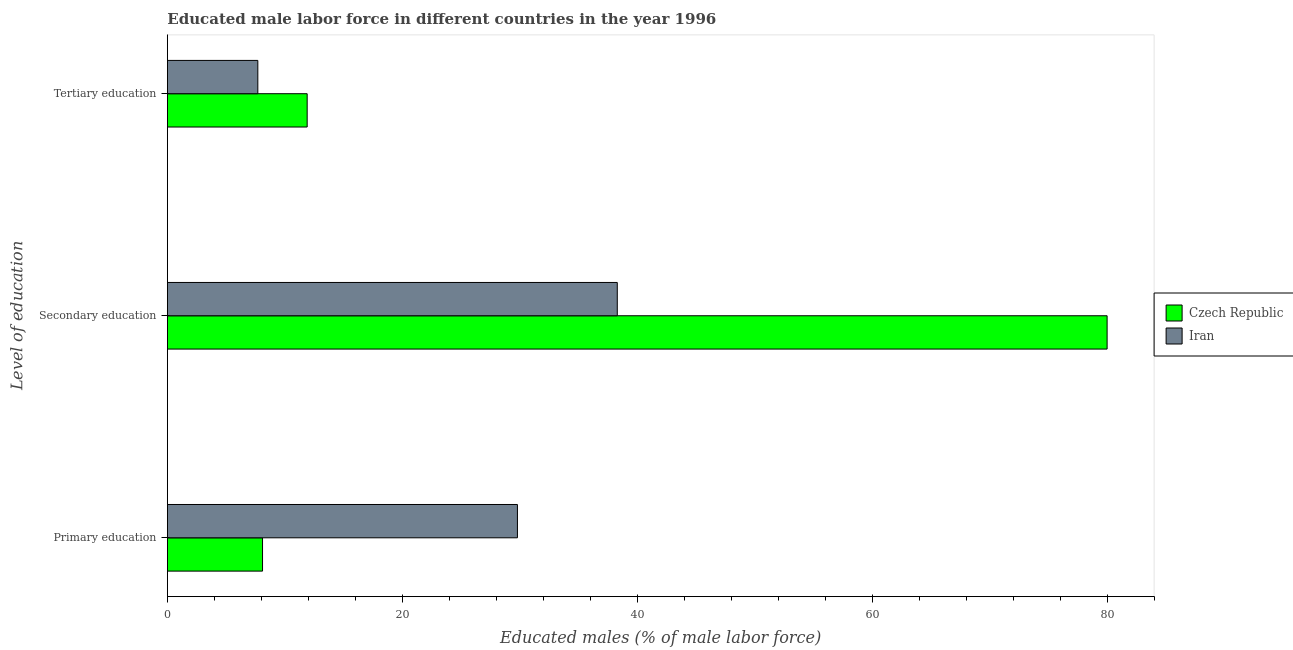How many different coloured bars are there?
Make the answer very short. 2. How many bars are there on the 3rd tick from the top?
Your answer should be compact. 2. How many bars are there on the 3rd tick from the bottom?
Keep it short and to the point. 2. What is the label of the 1st group of bars from the top?
Offer a terse response. Tertiary education. What is the percentage of male labor force who received secondary education in Iran?
Provide a short and direct response. 38.3. Across all countries, what is the maximum percentage of male labor force who received primary education?
Your response must be concise. 29.8. Across all countries, what is the minimum percentage of male labor force who received primary education?
Offer a very short reply. 8.1. In which country was the percentage of male labor force who received primary education maximum?
Provide a short and direct response. Iran. In which country was the percentage of male labor force who received tertiary education minimum?
Make the answer very short. Iran. What is the total percentage of male labor force who received secondary education in the graph?
Give a very brief answer. 118.3. What is the difference between the percentage of male labor force who received tertiary education in Czech Republic and that in Iran?
Give a very brief answer. 4.2. What is the difference between the percentage of male labor force who received secondary education in Czech Republic and the percentage of male labor force who received tertiary education in Iran?
Offer a very short reply. 72.3. What is the average percentage of male labor force who received primary education per country?
Your response must be concise. 18.95. What is the difference between the percentage of male labor force who received primary education and percentage of male labor force who received tertiary education in Iran?
Your answer should be compact. 22.1. In how many countries, is the percentage of male labor force who received tertiary education greater than 32 %?
Your answer should be very brief. 0. What is the ratio of the percentage of male labor force who received secondary education in Czech Republic to that in Iran?
Keep it short and to the point. 2.09. What is the difference between the highest and the second highest percentage of male labor force who received secondary education?
Provide a succinct answer. 41.7. What is the difference between the highest and the lowest percentage of male labor force who received primary education?
Offer a very short reply. 21.7. In how many countries, is the percentage of male labor force who received tertiary education greater than the average percentage of male labor force who received tertiary education taken over all countries?
Your answer should be very brief. 1. What does the 1st bar from the top in Tertiary education represents?
Give a very brief answer. Iran. What does the 1st bar from the bottom in Tertiary education represents?
Offer a terse response. Czech Republic. Is it the case that in every country, the sum of the percentage of male labor force who received primary education and percentage of male labor force who received secondary education is greater than the percentage of male labor force who received tertiary education?
Provide a succinct answer. Yes. What is the difference between two consecutive major ticks on the X-axis?
Make the answer very short. 20. Are the values on the major ticks of X-axis written in scientific E-notation?
Give a very brief answer. No. Does the graph contain any zero values?
Offer a very short reply. No. Does the graph contain grids?
Provide a succinct answer. No. Where does the legend appear in the graph?
Offer a terse response. Center right. What is the title of the graph?
Give a very brief answer. Educated male labor force in different countries in the year 1996. What is the label or title of the X-axis?
Offer a very short reply. Educated males (% of male labor force). What is the label or title of the Y-axis?
Your answer should be compact. Level of education. What is the Educated males (% of male labor force) in Czech Republic in Primary education?
Provide a succinct answer. 8.1. What is the Educated males (% of male labor force) in Iran in Primary education?
Keep it short and to the point. 29.8. What is the Educated males (% of male labor force) in Iran in Secondary education?
Provide a succinct answer. 38.3. What is the Educated males (% of male labor force) of Czech Republic in Tertiary education?
Keep it short and to the point. 11.9. What is the Educated males (% of male labor force) of Iran in Tertiary education?
Keep it short and to the point. 7.7. Across all Level of education, what is the maximum Educated males (% of male labor force) in Iran?
Ensure brevity in your answer.  38.3. Across all Level of education, what is the minimum Educated males (% of male labor force) in Czech Republic?
Your answer should be compact. 8.1. Across all Level of education, what is the minimum Educated males (% of male labor force) of Iran?
Your answer should be very brief. 7.7. What is the total Educated males (% of male labor force) in Czech Republic in the graph?
Provide a succinct answer. 100. What is the total Educated males (% of male labor force) in Iran in the graph?
Your response must be concise. 75.8. What is the difference between the Educated males (% of male labor force) in Czech Republic in Primary education and that in Secondary education?
Your response must be concise. -71.9. What is the difference between the Educated males (% of male labor force) in Iran in Primary education and that in Secondary education?
Provide a short and direct response. -8.5. What is the difference between the Educated males (% of male labor force) of Czech Republic in Primary education and that in Tertiary education?
Offer a very short reply. -3.8. What is the difference between the Educated males (% of male labor force) of Iran in Primary education and that in Tertiary education?
Provide a succinct answer. 22.1. What is the difference between the Educated males (% of male labor force) in Czech Republic in Secondary education and that in Tertiary education?
Offer a very short reply. 68.1. What is the difference between the Educated males (% of male labor force) of Iran in Secondary education and that in Tertiary education?
Give a very brief answer. 30.6. What is the difference between the Educated males (% of male labor force) in Czech Republic in Primary education and the Educated males (% of male labor force) in Iran in Secondary education?
Provide a short and direct response. -30.2. What is the difference between the Educated males (% of male labor force) of Czech Republic in Primary education and the Educated males (% of male labor force) of Iran in Tertiary education?
Make the answer very short. 0.4. What is the difference between the Educated males (% of male labor force) of Czech Republic in Secondary education and the Educated males (% of male labor force) of Iran in Tertiary education?
Offer a terse response. 72.3. What is the average Educated males (% of male labor force) in Czech Republic per Level of education?
Keep it short and to the point. 33.33. What is the average Educated males (% of male labor force) of Iran per Level of education?
Give a very brief answer. 25.27. What is the difference between the Educated males (% of male labor force) of Czech Republic and Educated males (% of male labor force) of Iran in Primary education?
Provide a short and direct response. -21.7. What is the difference between the Educated males (% of male labor force) in Czech Republic and Educated males (% of male labor force) in Iran in Secondary education?
Give a very brief answer. 41.7. What is the difference between the Educated males (% of male labor force) of Czech Republic and Educated males (% of male labor force) of Iran in Tertiary education?
Your answer should be very brief. 4.2. What is the ratio of the Educated males (% of male labor force) in Czech Republic in Primary education to that in Secondary education?
Provide a short and direct response. 0.1. What is the ratio of the Educated males (% of male labor force) of Iran in Primary education to that in Secondary education?
Ensure brevity in your answer.  0.78. What is the ratio of the Educated males (% of male labor force) of Czech Republic in Primary education to that in Tertiary education?
Your answer should be very brief. 0.68. What is the ratio of the Educated males (% of male labor force) of Iran in Primary education to that in Tertiary education?
Your answer should be compact. 3.87. What is the ratio of the Educated males (% of male labor force) in Czech Republic in Secondary education to that in Tertiary education?
Offer a terse response. 6.72. What is the ratio of the Educated males (% of male labor force) in Iran in Secondary education to that in Tertiary education?
Provide a short and direct response. 4.97. What is the difference between the highest and the second highest Educated males (% of male labor force) of Czech Republic?
Keep it short and to the point. 68.1. What is the difference between the highest and the second highest Educated males (% of male labor force) in Iran?
Your response must be concise. 8.5. What is the difference between the highest and the lowest Educated males (% of male labor force) in Czech Republic?
Provide a short and direct response. 71.9. What is the difference between the highest and the lowest Educated males (% of male labor force) of Iran?
Your answer should be very brief. 30.6. 